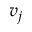<formula> <loc_0><loc_0><loc_500><loc_500>v _ { j }</formula> 